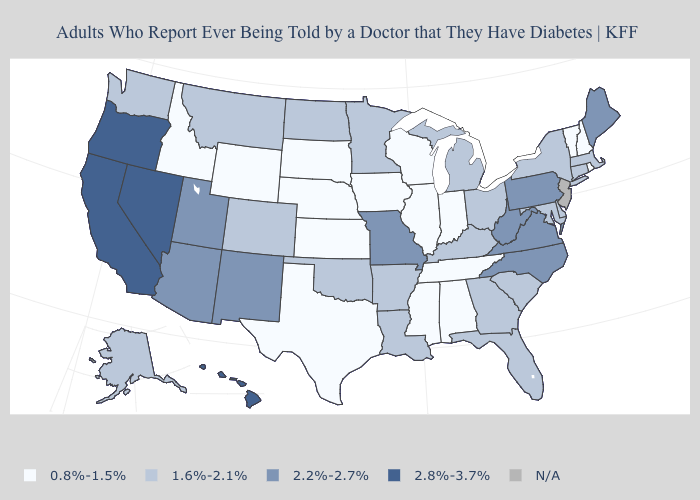What is the value of New Hampshire?
Answer briefly. 0.8%-1.5%. What is the value of North Dakota?
Concise answer only. 1.6%-2.1%. Name the states that have a value in the range 1.6%-2.1%?
Quick response, please. Alaska, Arkansas, Colorado, Connecticut, Delaware, Florida, Georgia, Kentucky, Louisiana, Maryland, Massachusetts, Michigan, Minnesota, Montana, New York, North Dakota, Ohio, Oklahoma, South Carolina, Washington. How many symbols are there in the legend?
Write a very short answer. 5. What is the value of Nevada?
Write a very short answer. 2.8%-3.7%. How many symbols are there in the legend?
Keep it brief. 5. What is the value of New Mexico?
Be succinct. 2.2%-2.7%. What is the value of Ohio?
Be succinct. 1.6%-2.1%. Which states have the lowest value in the Northeast?
Be succinct. New Hampshire, Rhode Island, Vermont. Among the states that border Arkansas , which have the highest value?
Be succinct. Missouri. Among the states that border Washington , which have the highest value?
Be succinct. Oregon. What is the value of West Virginia?
Keep it brief. 2.2%-2.7%. 